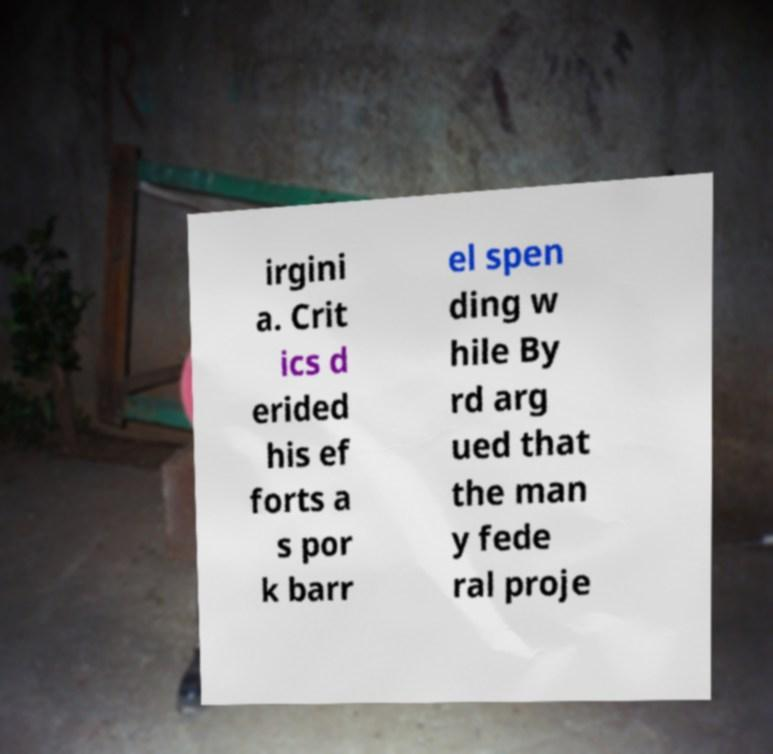Could you extract and type out the text from this image? irgini a. Crit ics d erided his ef forts a s por k barr el spen ding w hile By rd arg ued that the man y fede ral proje 